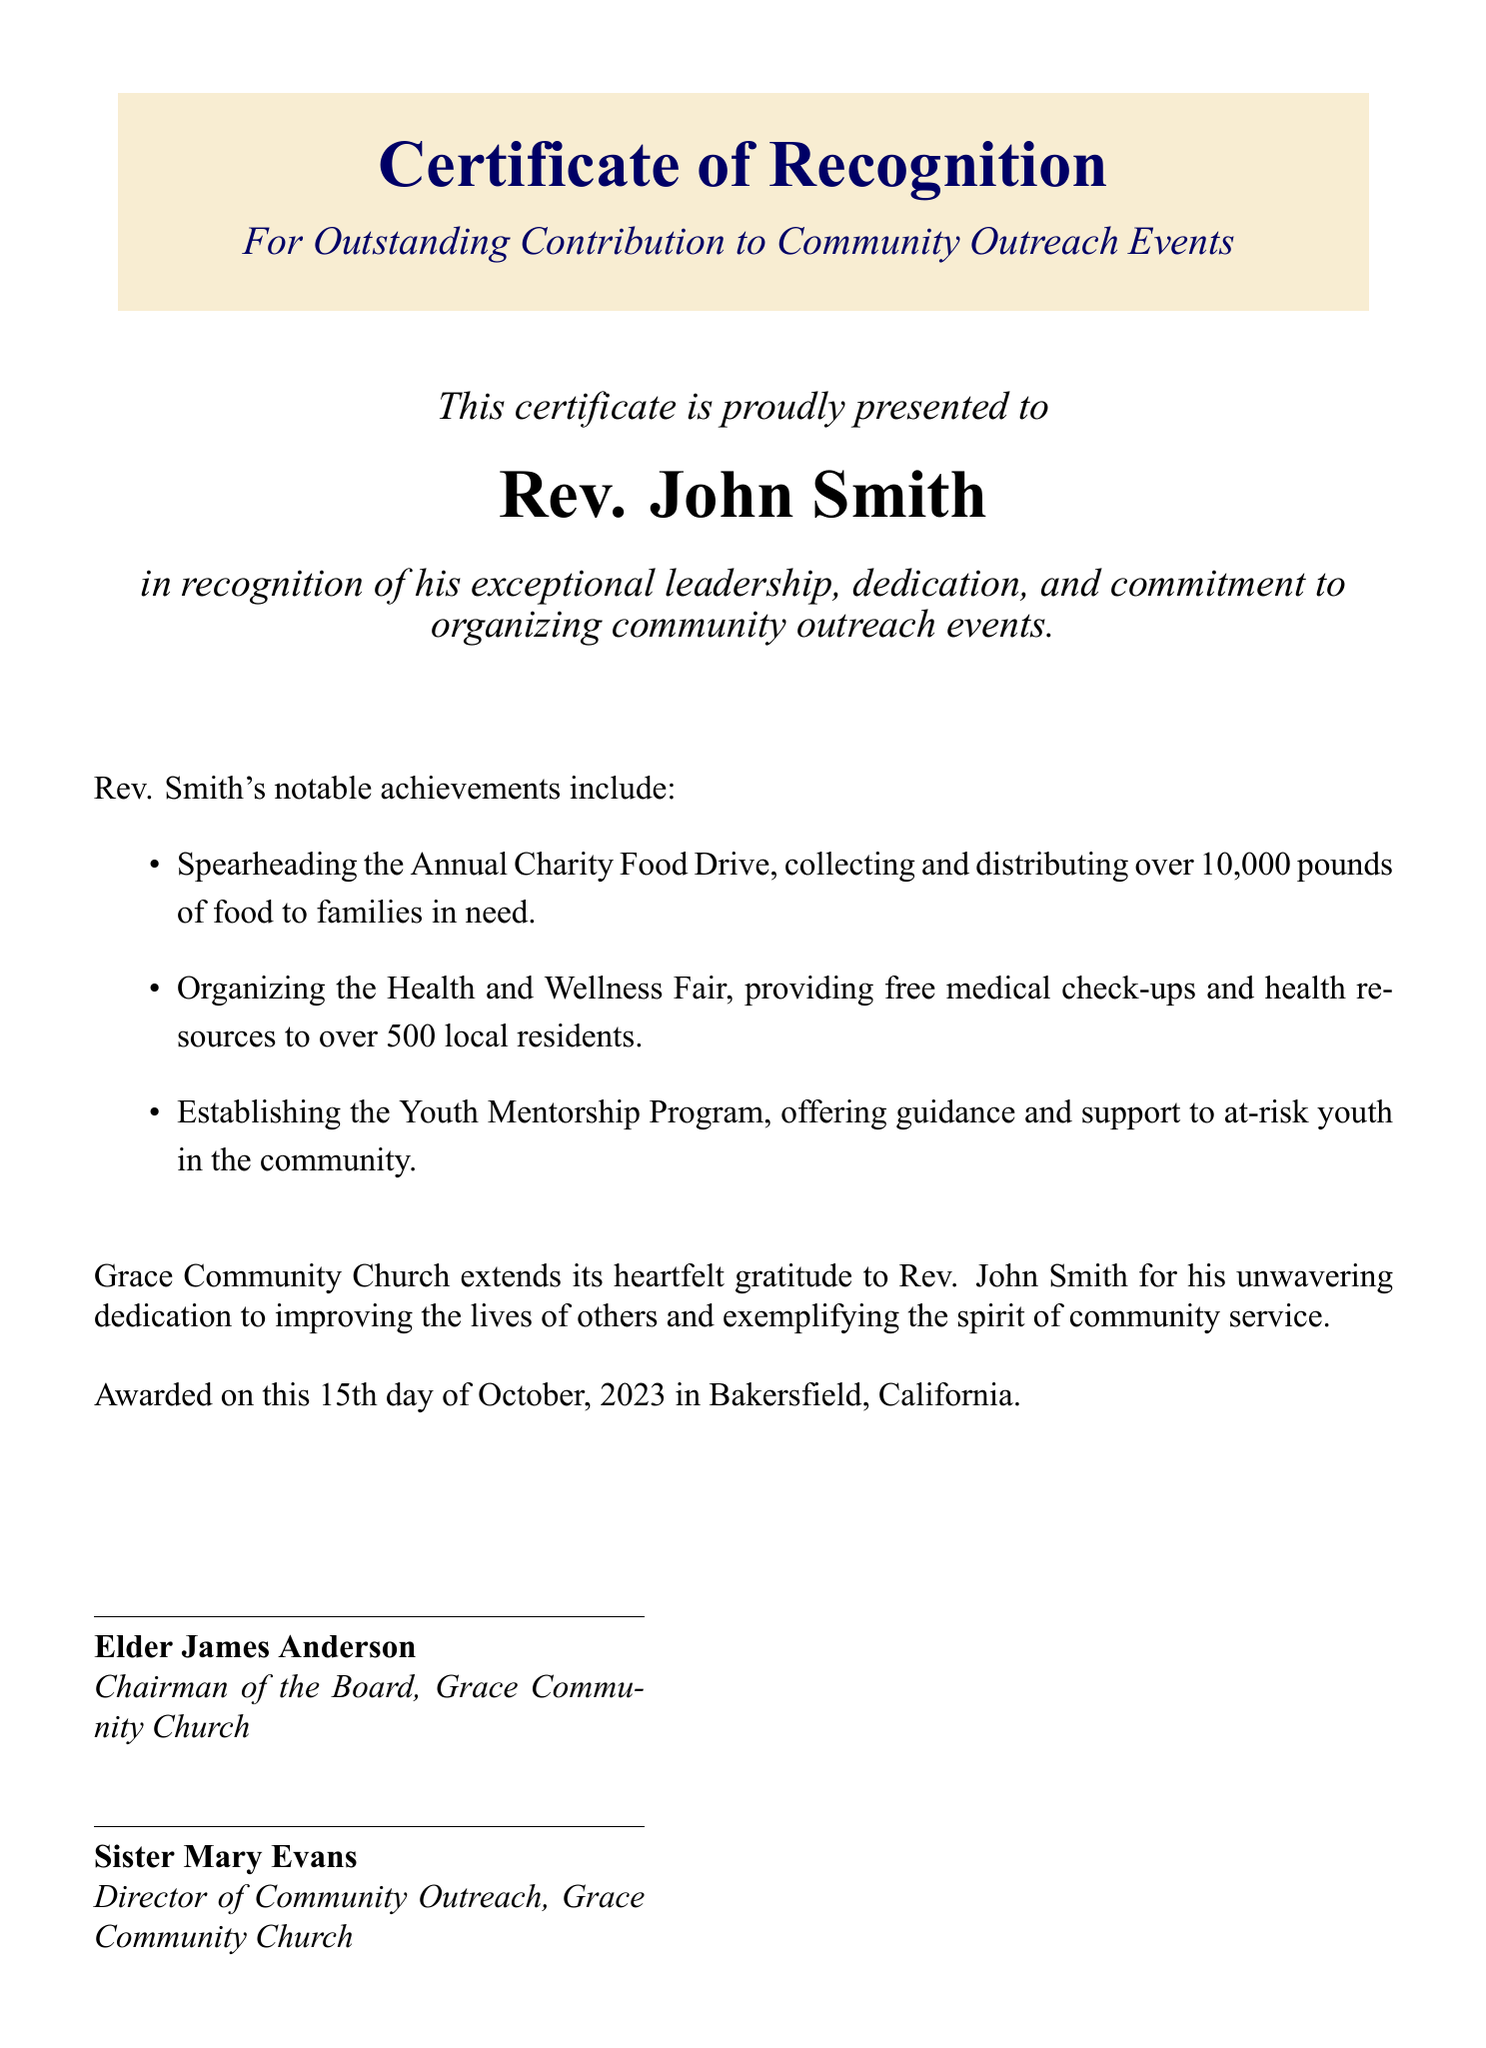What is the title of the document? The title of the document is prominently displayed at the top and identifies it as a Certificate of Recognition.
Answer: Certificate of Recognition Who is the certificate awarded to? The recipient's name is specifically stated below the title, identifying the person being recognized.
Answer: Rev. John Smith What organization issued the certificate? The organization responsible for issuing the certificate is mentioned at the end of the document in the acknowledgment section.
Answer: Grace Community Church What is the date of the award? The date is specified at the bottom of the document, indicating when the certificate was awarded.
Answer: 15th day of October, 2023 How many pounds of food were collected during the charity food drive? The document states the amount of food collected during the food drive as a specific number.
Answer: 10,000 pounds What event provided free medical check-ups? The event where free medical check-ups were provided is detailed in the list of Rev. Smith's notable achievements.
Answer: Health and Wellness Fair Who signed the certificate as the Chairman of the Board? The signature section identifies the person holding the position of Chairman of the Board.
Answer: Elder James Anderson What program supports at-risk youth? The document mentions a specific program aimed at helping at-risk youth in the community.
Answer: Youth Mentorship Program 